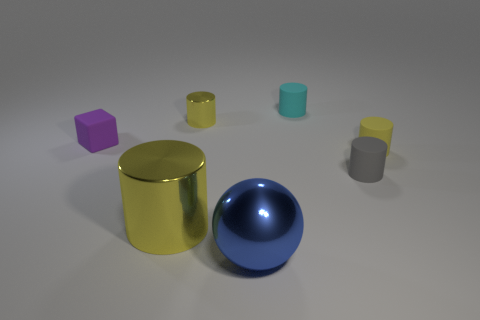What number of other things are there of the same material as the small block
Provide a short and direct response. 3. What number of things are either yellow metal things that are behind the small gray cylinder or yellow cylinders on the left side of the big blue ball?
Offer a very short reply. 2. Do the metal thing that is behind the tiny purple rubber cube and the big metallic object that is behind the blue object have the same shape?
Keep it short and to the point. Yes. There is a yellow thing that is the same size as the blue metallic sphere; what is its shape?
Keep it short and to the point. Cylinder. How many rubber objects are tiny cyan cylinders or big cyan cubes?
Ensure brevity in your answer.  1. Is the yellow object that is on the left side of the small metallic cylinder made of the same material as the small yellow cylinder that is left of the blue shiny thing?
Your answer should be compact. Yes. There is a tiny cylinder that is the same material as the blue object; what color is it?
Ensure brevity in your answer.  Yellow. Is the number of gray things that are in front of the small yellow matte cylinder greater than the number of cyan matte things in front of the gray rubber cylinder?
Your answer should be compact. Yes. Is there a small rubber thing?
Ensure brevity in your answer.  Yes. What material is the other tiny cylinder that is the same color as the small shiny cylinder?
Offer a very short reply. Rubber. 